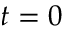<formula> <loc_0><loc_0><loc_500><loc_500>t = 0</formula> 